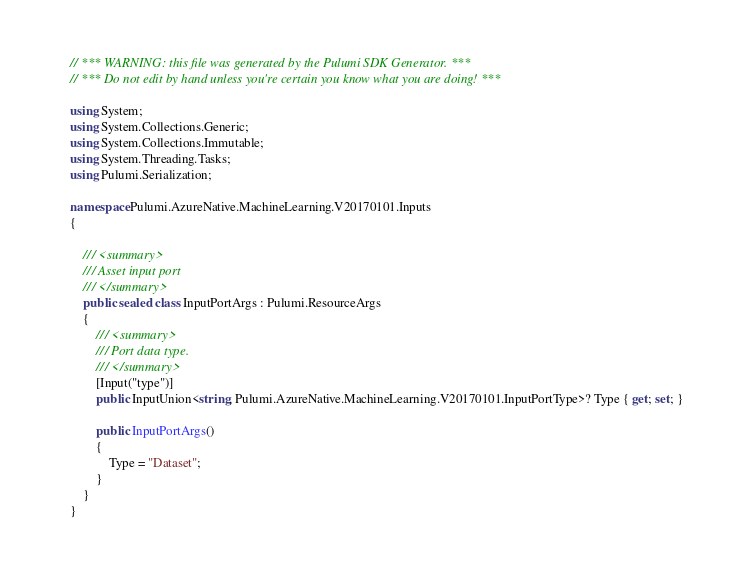<code> <loc_0><loc_0><loc_500><loc_500><_C#_>// *** WARNING: this file was generated by the Pulumi SDK Generator. ***
// *** Do not edit by hand unless you're certain you know what you are doing! ***

using System;
using System.Collections.Generic;
using System.Collections.Immutable;
using System.Threading.Tasks;
using Pulumi.Serialization;

namespace Pulumi.AzureNative.MachineLearning.V20170101.Inputs
{

    /// <summary>
    /// Asset input port
    /// </summary>
    public sealed class InputPortArgs : Pulumi.ResourceArgs
    {
        /// <summary>
        /// Port data type.
        /// </summary>
        [Input("type")]
        public InputUnion<string, Pulumi.AzureNative.MachineLearning.V20170101.InputPortType>? Type { get; set; }

        public InputPortArgs()
        {
            Type = "Dataset";
        }
    }
}
</code> 